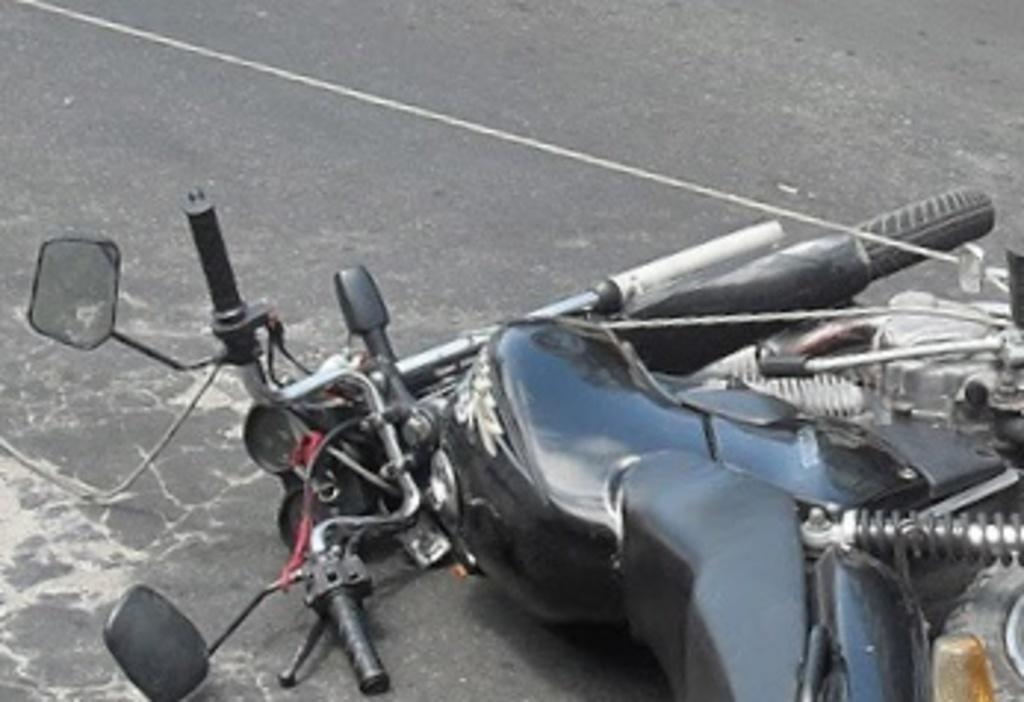What type of motor vehicle is in the image? There is a motor vehicle in the image, but the specific type is not mentioned. What is the condition of the motor vehicle in the image? The motor vehicle has fallen down on the road. What type of blade can be seen cutting through the night in the image? There is no blade or reference to nighttime in the image; it features a fallen motor vehicle on the road. 